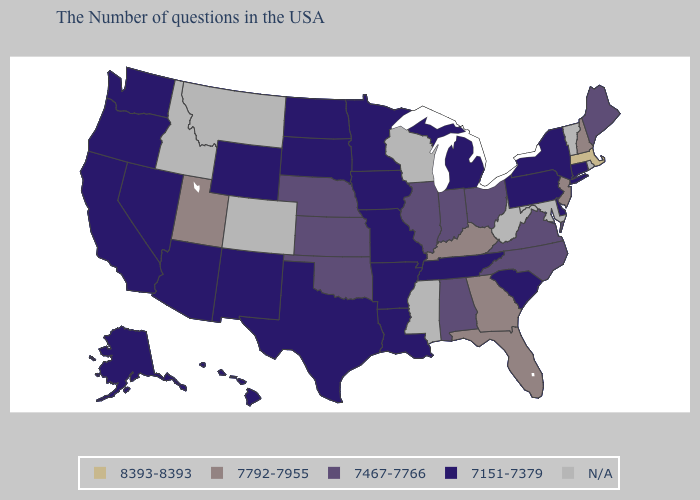Name the states that have a value in the range 7467-7766?
Short answer required. Maine, Virginia, North Carolina, Ohio, Indiana, Alabama, Illinois, Kansas, Nebraska, Oklahoma. Does Massachusetts have the highest value in the USA?
Quick response, please. Yes. What is the value of Indiana?
Keep it brief. 7467-7766. Among the states that border Nebraska , does Kansas have the highest value?
Write a very short answer. Yes. Which states have the lowest value in the Northeast?
Write a very short answer. Connecticut, New York, Pennsylvania. Which states have the lowest value in the West?
Keep it brief. Wyoming, New Mexico, Arizona, Nevada, California, Washington, Oregon, Alaska, Hawaii. How many symbols are there in the legend?
Concise answer only. 5. Which states have the lowest value in the USA?
Quick response, please. Connecticut, New York, Delaware, Pennsylvania, South Carolina, Michigan, Tennessee, Louisiana, Missouri, Arkansas, Minnesota, Iowa, Texas, South Dakota, North Dakota, Wyoming, New Mexico, Arizona, Nevada, California, Washington, Oregon, Alaska, Hawaii. What is the value of Maine?
Answer briefly. 7467-7766. What is the value of North Dakota?
Quick response, please. 7151-7379. What is the highest value in the MidWest ?
Short answer required. 7467-7766. What is the value of North Dakota?
Short answer required. 7151-7379. Does the map have missing data?
Short answer required. Yes. Which states have the lowest value in the MidWest?
Write a very short answer. Michigan, Missouri, Minnesota, Iowa, South Dakota, North Dakota. 